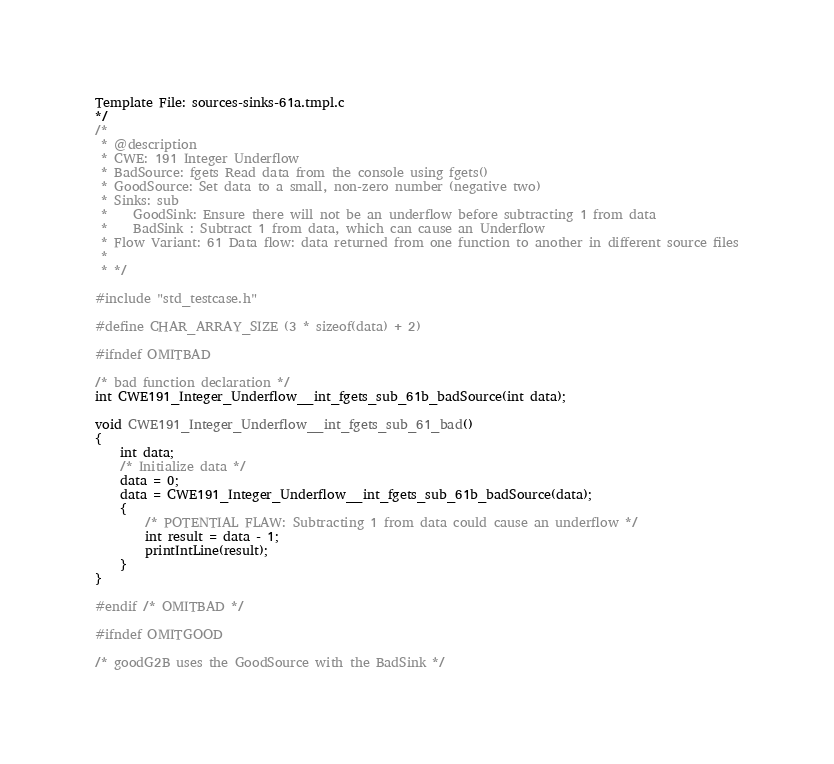Convert code to text. <code><loc_0><loc_0><loc_500><loc_500><_C_>Template File: sources-sinks-61a.tmpl.c
*/
/*
 * @description
 * CWE: 191 Integer Underflow
 * BadSource: fgets Read data from the console using fgets()
 * GoodSource: Set data to a small, non-zero number (negative two)
 * Sinks: sub
 *    GoodSink: Ensure there will not be an underflow before subtracting 1 from data
 *    BadSink : Subtract 1 from data, which can cause an Underflow
 * Flow Variant: 61 Data flow: data returned from one function to another in different source files
 *
 * */

#include "std_testcase.h"

#define CHAR_ARRAY_SIZE (3 * sizeof(data) + 2)

#ifndef OMITBAD

/* bad function declaration */
int CWE191_Integer_Underflow__int_fgets_sub_61b_badSource(int data);

void CWE191_Integer_Underflow__int_fgets_sub_61_bad()
{
    int data;
    /* Initialize data */
    data = 0;
    data = CWE191_Integer_Underflow__int_fgets_sub_61b_badSource(data);
    {
        /* POTENTIAL FLAW: Subtracting 1 from data could cause an underflow */
        int result = data - 1;
        printIntLine(result);
    }
}

#endif /* OMITBAD */

#ifndef OMITGOOD

/* goodG2B uses the GoodSource with the BadSink */</code> 